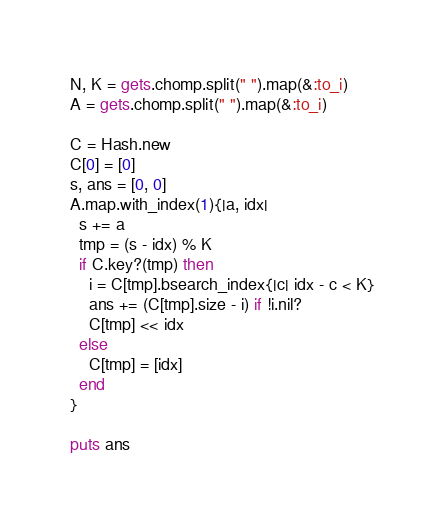<code> <loc_0><loc_0><loc_500><loc_500><_Ruby_>N, K = gets.chomp.split(" ").map(&:to_i)
A = gets.chomp.split(" ").map(&:to_i)

C = Hash.new
C[0] = [0]
s, ans = [0, 0]
A.map.with_index(1){|a, idx|
  s += a
  tmp = (s - idx) % K
  if C.key?(tmp) then
    i = C[tmp].bsearch_index{|c| idx - c < K}
    ans += (C[tmp].size - i) if !i.nil?
    C[tmp] << idx
  else
    C[tmp] = [idx]
  end
}

puts ans
</code> 